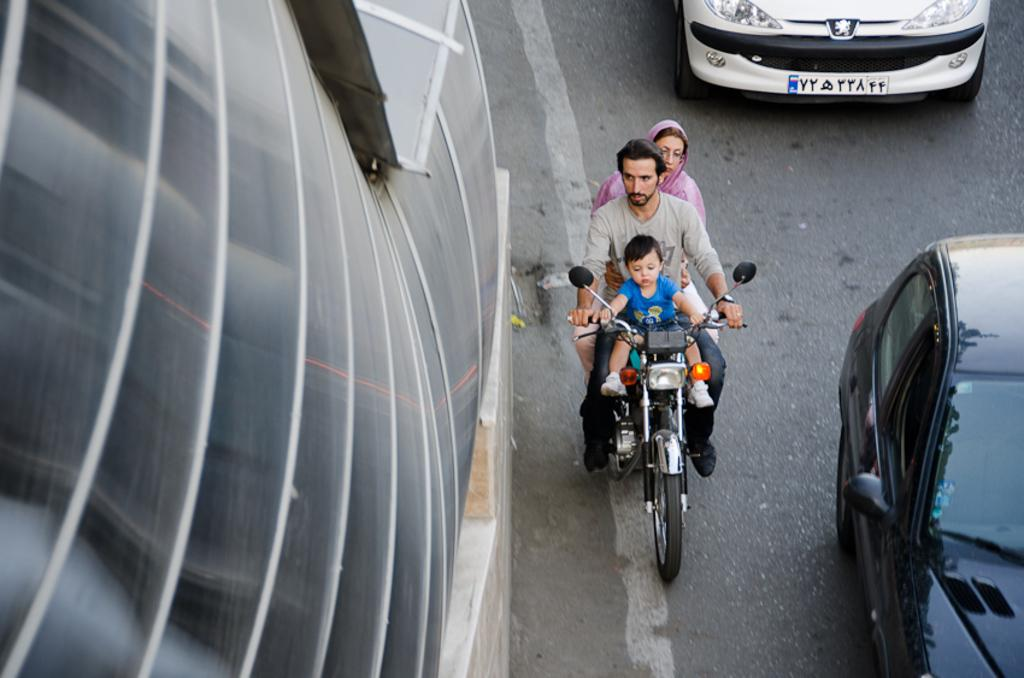How many people are on the bike in the image? There are three persons on a bike in the image. What else can be seen on the road in the image? There are vehicles visible on the road in the image. What type of building can be seen in the image? There is a glass building in the image. What type of business is being conducted at the table in the image? There is no table present in the image, so it is not possible to answer that question. 